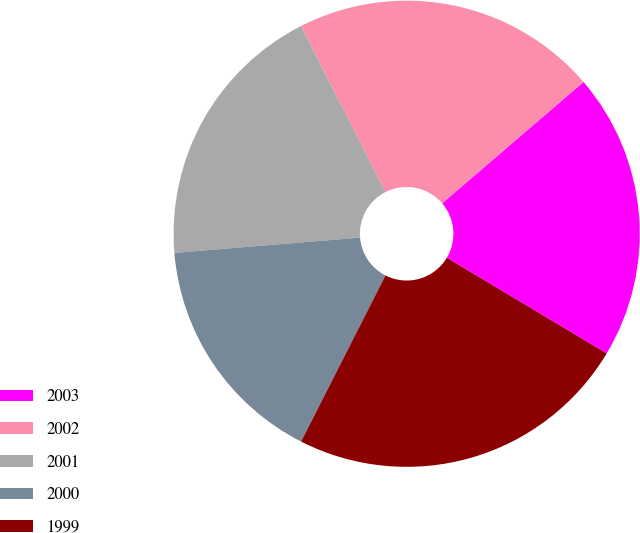Convert chart. <chart><loc_0><loc_0><loc_500><loc_500><pie_chart><fcel>2003<fcel>2002<fcel>2001<fcel>2000<fcel>1999<nl><fcel>19.87%<fcel>21.2%<fcel>18.82%<fcel>16.21%<fcel>23.9%<nl></chart> 